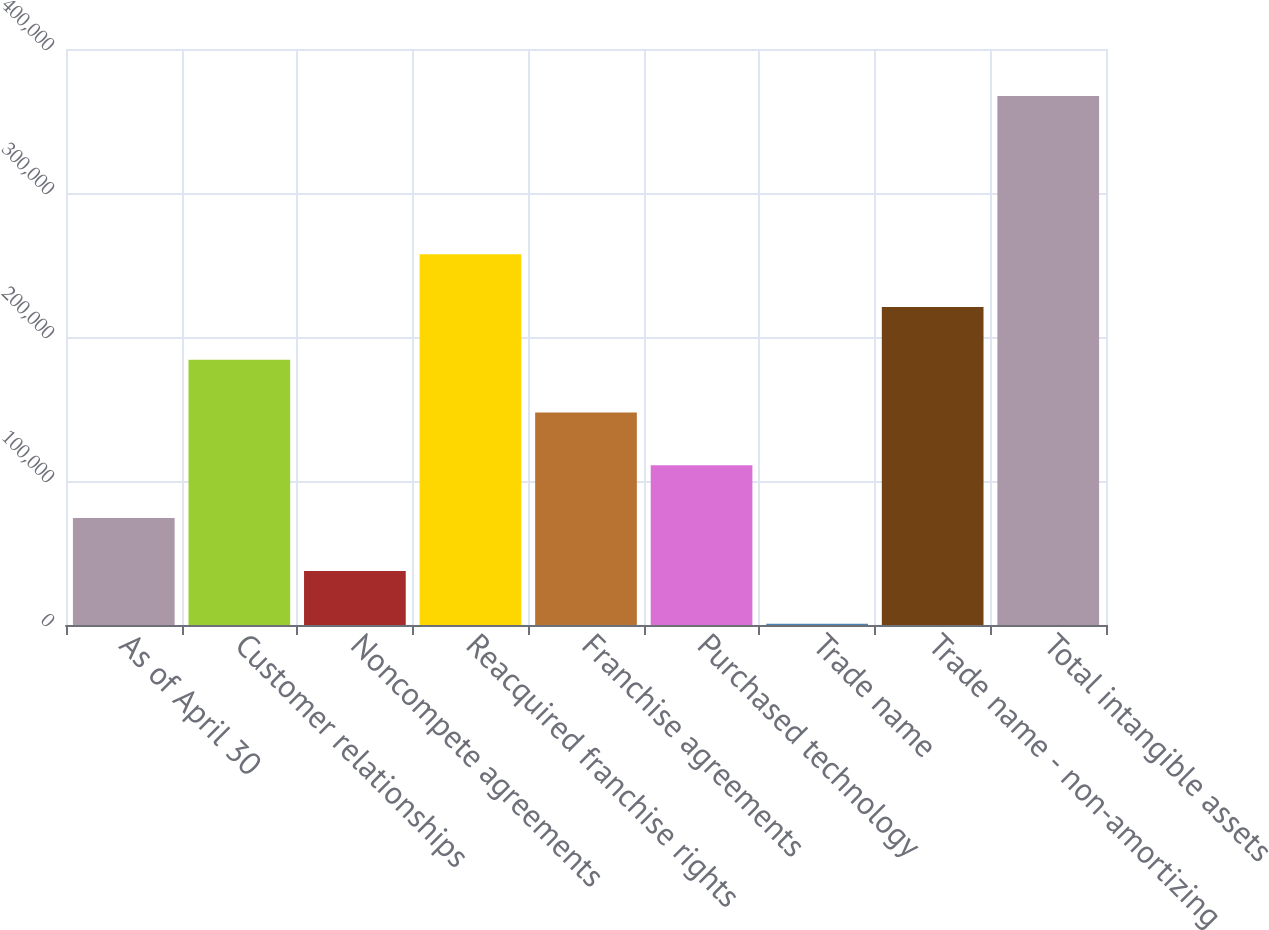<chart> <loc_0><loc_0><loc_500><loc_500><bar_chart><fcel>As of April 30<fcel>Customer relationships<fcel>Noncompete agreements<fcel>Reacquired franchise rights<fcel>Franchise agreements<fcel>Purchased technology<fcel>Trade name<fcel>Trade name - non-amortizing<fcel>Total intangible assets<nl><fcel>74226.4<fcel>184178<fcel>37575.7<fcel>257480<fcel>147528<fcel>110877<fcel>925<fcel>220829<fcel>367432<nl></chart> 